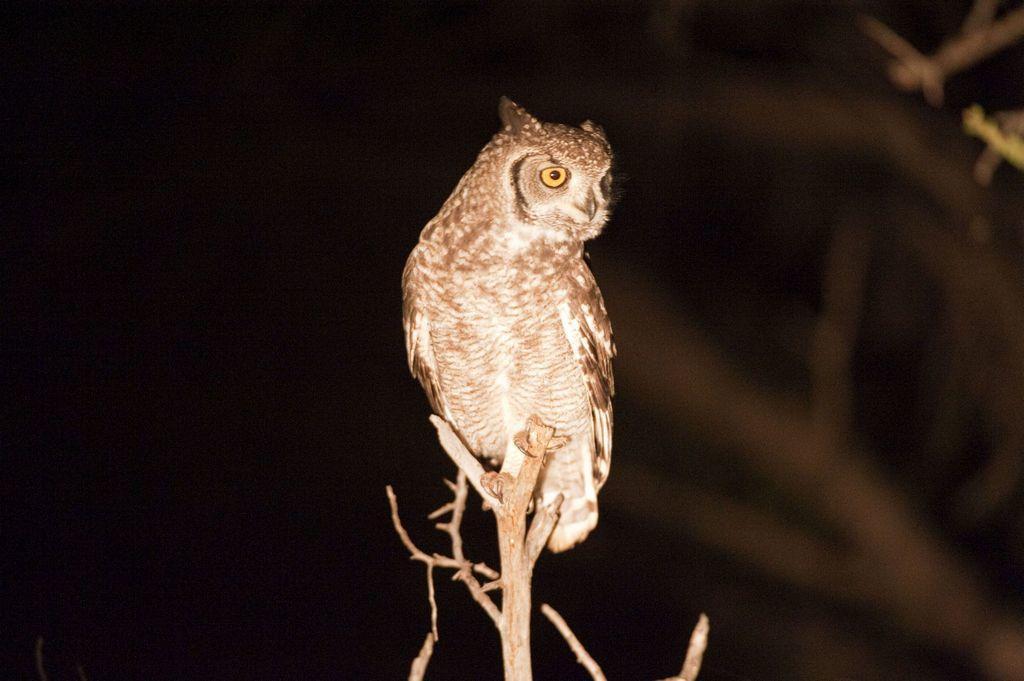Describe this image in one or two sentences. In this picture I can observe an owl. This owl is in brown color. The background is completely dark. 